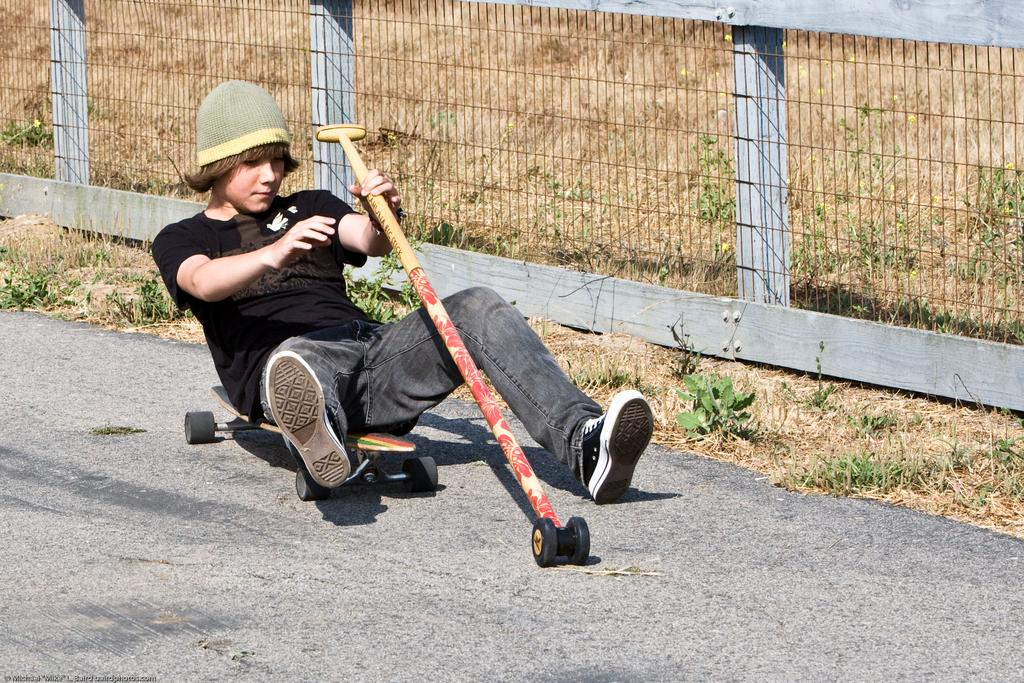What is the person in the image wearing? The person is wearing a black dress. What is the person sitting on in the image? The person is sitting on a skateboard. Where is the skateboard located? The skateboard is on the road. What is the person holding in the image? The person is holding a stick with a wheel attached to it. What can be seen beside the person in the image? There is a fence beside the person. What type of poison is the person using to control the twig in the image? There is no poison or twig present in the image. What religious symbol can be seen on the person's clothing in the image? There is no religious symbol mentioned or visible on the person's clothing in the image. 